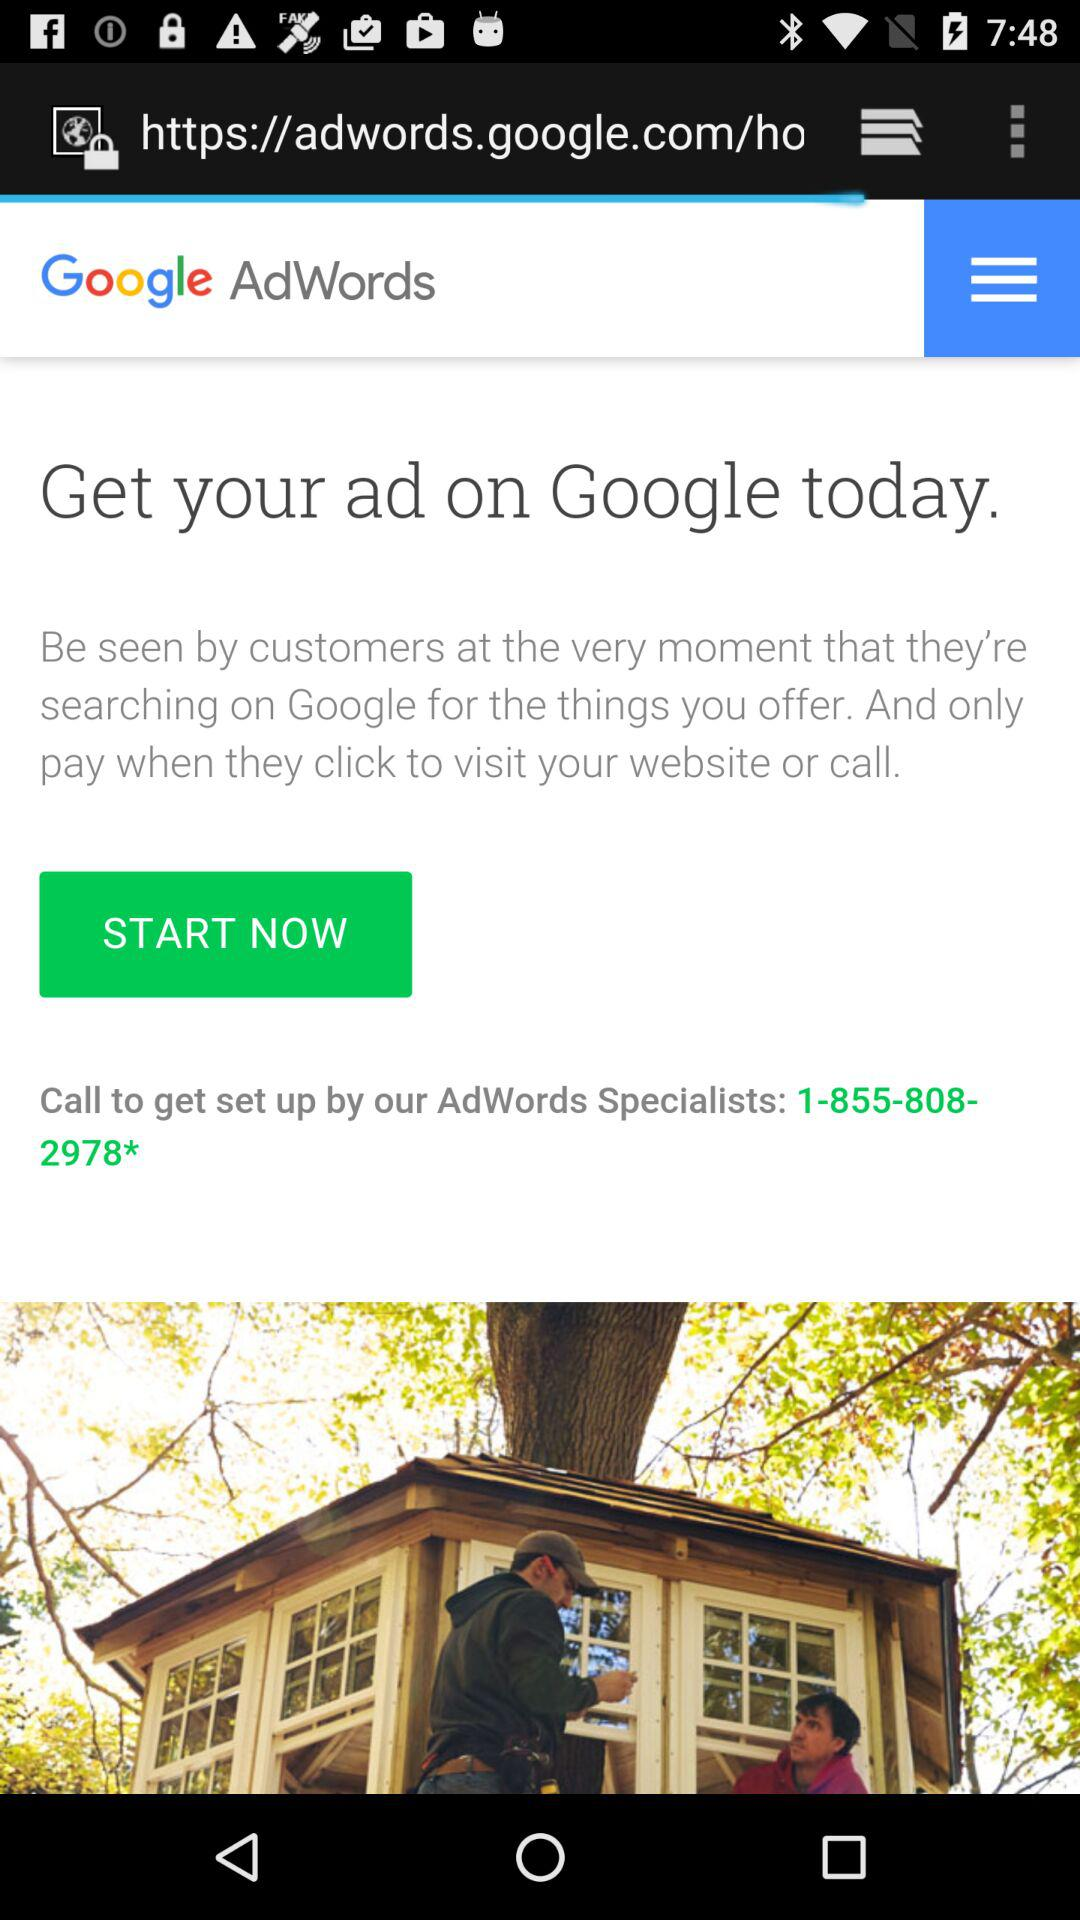What number do we need to call to get set up by AdWords experts? The number you need to call is "1-855-808-2978*". 